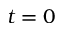Convert formula to latex. <formula><loc_0><loc_0><loc_500><loc_500>t = 0</formula> 